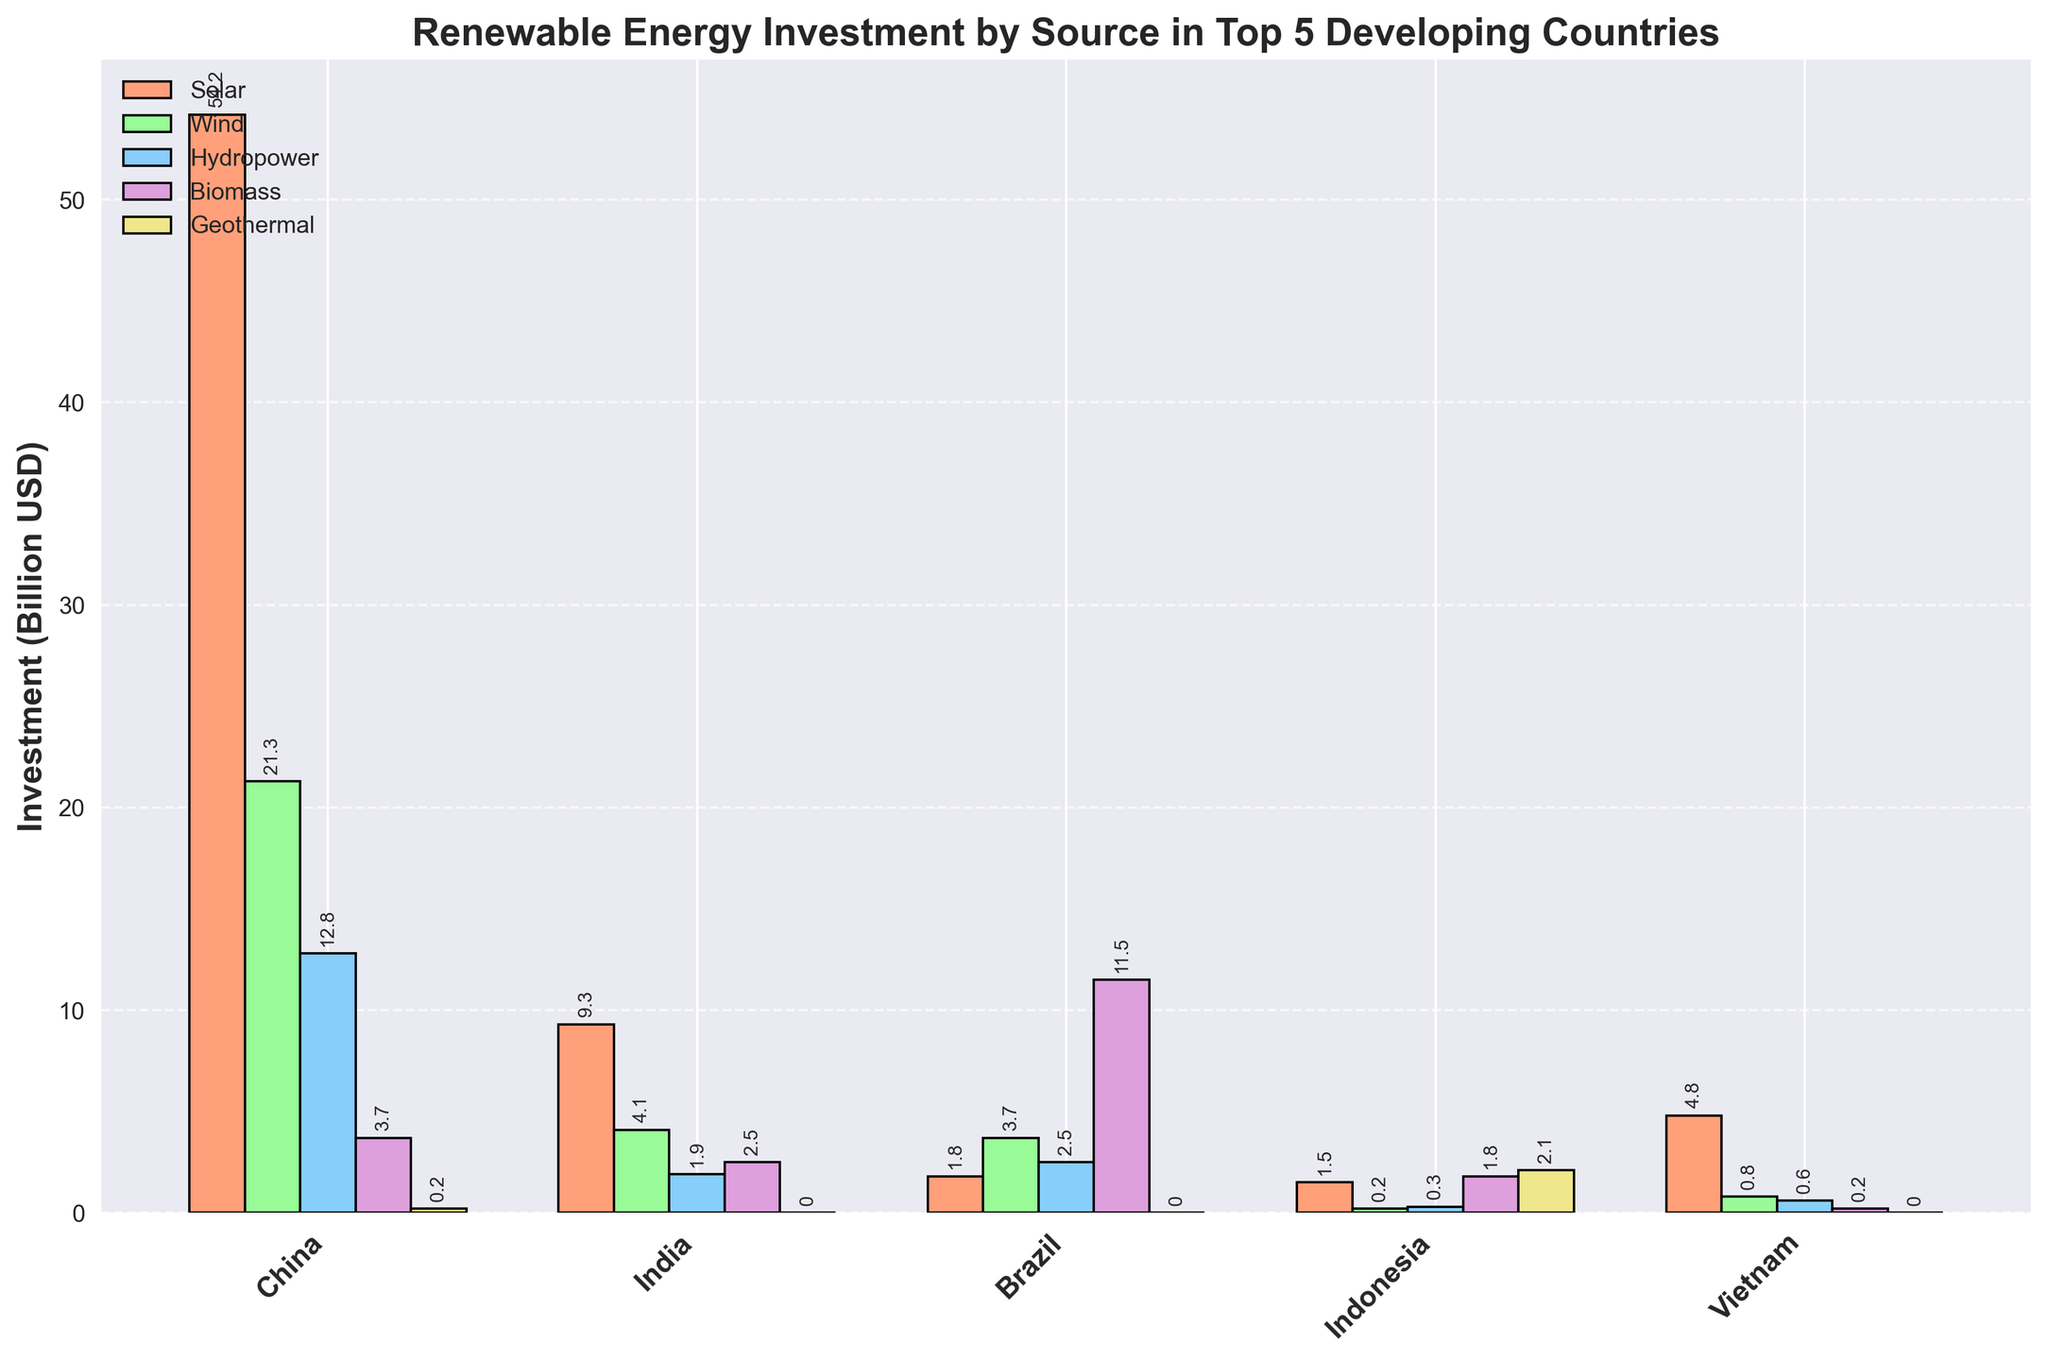Which country has the highest investment in Solar energy, and what is the value? From the bar chart, look for the bar corresponding to Solar energy (in orange) that is the tallest. This corresponds to China. The y-axis value is approximately 54.2.
Answer: China, 54.2 Which country invests the most in Hydropower? Identify the bar that represents Hydropower (in blue) with the largest height. This is in China with a value around 12.8.
Answer: China, 12.8 Compare India's investment in Wind and Biomass. Which is higher? Look at the bars for India. Wind is represented by the green bar and Biomass by the purple bar. The Wind bar is at about 4.1, while Biomass is around 2.5. Thus, Wind investment is higher.
Answer: Wind Which energy source does Brazil invest in the most, and how much is the investment? Find the bars for Brazil and identify the tallest one. The tallest is the Biomass bar (purple), approximately 11.5.
Answer: Biomass, 11.5 What is the combined investment in Geothermal energy for all five countries? Sum the investments in Geothermal for each country: China (0.2) + India (0.0) + Brazil (0.0) + Indonesia (2.1) + Vietnam (0.0) = 2.1 + 0.2 = 2.3.
Answer: 2.3 Among the five countries, which has the least diverse investment in different renewable energy sources? Compare the variations in the height of the different colored bars within each country. India has more consistent low values across different sources, implying less diversity.
Answer: India How does Indonesia's total investment in all renewable sources compare to Vietnam's? Sum up the investment amounts for all energy sources for Indonesia and Vietnam. Indonesia: 1.5 + 0.2 + 0.3 + 1.8 + 2.1 = 5.9. Vietnam: 4.8 + 0.8 + 0.6 + 0.2 + 0.0 = 6.4. Vietnam's total investment is higher.
Answer: Vietnam What is the difference between China’s investments in Solar and Hydropower? Subtract Hydropower investment from Solar investment for China: 54.2 (Solar) - 12.8 (Hydropower) = 41.4.
Answer: 41.4 Which countries have an equal investment in Geothermal energy? Compare the height of the Geothermal bars (yellow) in the chart. Both India and Brazil have zero investment in Geothermal energy.
Answer: India and Brazil 